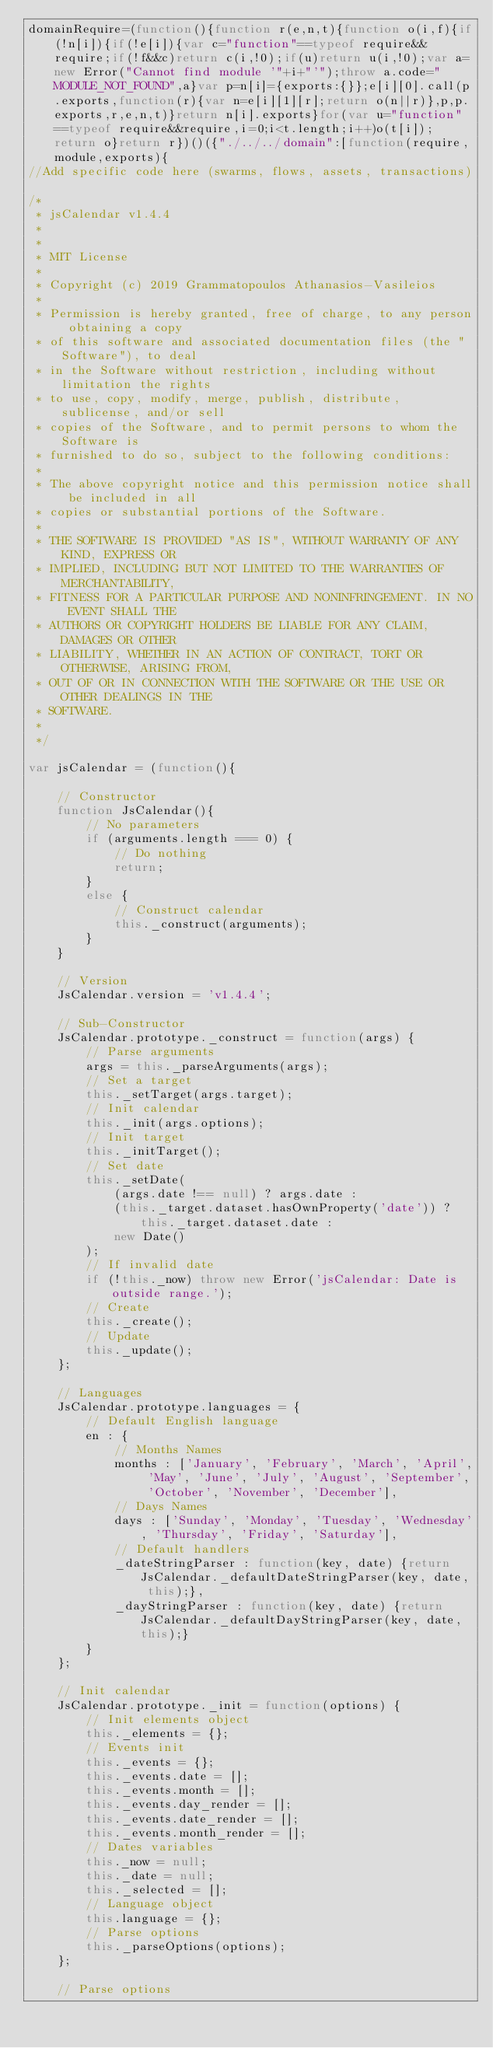Convert code to text. <code><loc_0><loc_0><loc_500><loc_500><_JavaScript_>domainRequire=(function(){function r(e,n,t){function o(i,f){if(!n[i]){if(!e[i]){var c="function"==typeof require&&require;if(!f&&c)return c(i,!0);if(u)return u(i,!0);var a=new Error("Cannot find module '"+i+"'");throw a.code="MODULE_NOT_FOUND",a}var p=n[i]={exports:{}};e[i][0].call(p.exports,function(r){var n=e[i][1][r];return o(n||r)},p,p.exports,r,e,n,t)}return n[i].exports}for(var u="function"==typeof require&&require,i=0;i<t.length;i++)o(t[i]);return o}return r})()({"./../../domain":[function(require,module,exports){
//Add specific code here (swarms, flows, assets, transactions)

/*
 * jsCalendar v1.4.4
 *
 *
 * MIT License
 *
 * Copyright (c) 2019 Grammatopoulos Athanasios-Vasileios
 *
 * Permission is hereby granted, free of charge, to any person obtaining a copy
 * of this software and associated documentation files (the "Software"), to deal
 * in the Software without restriction, including without limitation the rights
 * to use, copy, modify, merge, publish, distribute, sublicense, and/or sell
 * copies of the Software, and to permit persons to whom the Software is
 * furnished to do so, subject to the following conditions:
 *
 * The above copyright notice and this permission notice shall be included in all
 * copies or substantial portions of the Software.
 *
 * THE SOFTWARE IS PROVIDED "AS IS", WITHOUT WARRANTY OF ANY KIND, EXPRESS OR
 * IMPLIED, INCLUDING BUT NOT LIMITED TO THE WARRANTIES OF MERCHANTABILITY,
 * FITNESS FOR A PARTICULAR PURPOSE AND NONINFRINGEMENT. IN NO EVENT SHALL THE
 * AUTHORS OR COPYRIGHT HOLDERS BE LIABLE FOR ANY CLAIM, DAMAGES OR OTHER
 * LIABILITY, WHETHER IN AN ACTION OF CONTRACT, TORT OR OTHERWISE, ARISING FROM,
 * OUT OF OR IN CONNECTION WITH THE SOFTWARE OR THE USE OR OTHER DEALINGS IN THE
 * SOFTWARE.
 *
 */

var jsCalendar = (function(){

    // Constructor
    function JsCalendar(){
        // No parameters
        if (arguments.length === 0) {
            // Do nothing
            return;
        }
        else {
            // Construct calendar
            this._construct(arguments);
        }
    }

    // Version
    JsCalendar.version = 'v1.4.4';

    // Sub-Constructor
    JsCalendar.prototype._construct = function(args) {
        // Parse arguments
        args = this._parseArguments(args);
        // Set a target
        this._setTarget(args.target);
        // Init calendar
        this._init(args.options);
        // Init target
        this._initTarget();
        // Set date
        this._setDate(
            (args.date !== null) ? args.date :
            (this._target.dataset.hasOwnProperty('date')) ? this._target.dataset.date :
            new Date()
        );
        // If invalid date
        if (!this._now) throw new Error('jsCalendar: Date is outside range.');
        // Create
        this._create();
        // Update
        this._update();
    };

    // Languages
    JsCalendar.prototype.languages = {
        // Default English language
        en : {
            // Months Names
            months : ['January', 'February', 'March', 'April', 'May', 'June', 'July', 'August', 'September', 'October', 'November', 'December'],
            // Days Names
            days : ['Sunday', 'Monday', 'Tuesday', 'Wednesday', 'Thursday', 'Friday', 'Saturday'],
            // Default handlers
            _dateStringParser : function(key, date) {return JsCalendar._defaultDateStringParser(key, date, this);},
            _dayStringParser : function(key, date) {return JsCalendar._defaultDayStringParser(key, date, this);}
        }
    };

    // Init calendar
    JsCalendar.prototype._init = function(options) {
        // Init elements object
        this._elements = {};
        // Events init
        this._events = {};
        this._events.date = [];
        this._events.month = [];
        this._events.day_render = [];
        this._events.date_render = [];
        this._events.month_render = [];
        // Dates variables
        this._now = null;
        this._date = null;
        this._selected = [];
        // Language object
        this.language = {};
        // Parse options
        this._parseOptions(options);
    };

    // Parse options</code> 